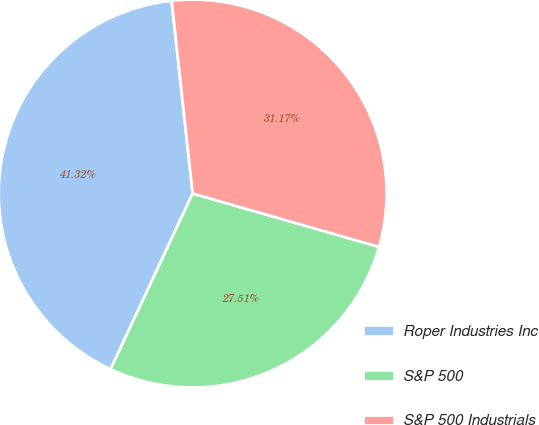<chart> <loc_0><loc_0><loc_500><loc_500><pie_chart><fcel>Roper Industries Inc<fcel>S&P 500<fcel>S&P 500 Industrials<nl><fcel>41.32%<fcel>27.51%<fcel>31.17%<nl></chart> 